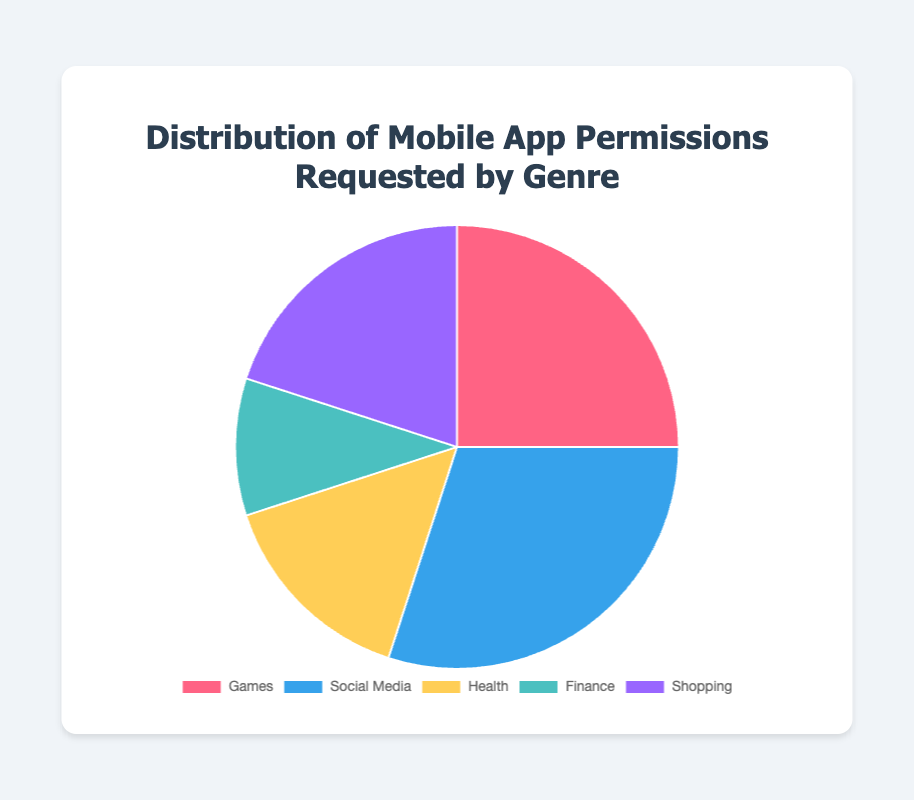What genre requests the highest percentage of permissions? The genre with the highest percentage of permissions is visible around the largest section of the pie chart. According to the data, Social Media requests the highest percentage of permissions at 30%.
Answer: Social Media Which genre requests the lowest percentage of permissions? The genre with the lowest percentage of permissions is visible around the smallest section of the pie chart. According to the data, Finance requests the lowest percentage at 10%.
Answer: Finance What is the total percentage of permissions requested by Games and Health combined? To find the total percentage of permissions requested by Games and Health, sum their individual percentages: 25 (Games) + 15 (Health) = 40.
Answer: 40 By how much does the percentage of permissions requested by Social Media exceed that requested by Shopping? To find how much more Social Media requests, subtract the percentage of Shopping from that of Social Media: 30 (Social Media) - 20 (Shopping) = 10.
Answer: 10 Which genre requests more permissions, Games or Shopping? By comparing the sizes of the sections in the pie chart, we see that Games (25%) requests more permissions than Shopping (20%).
Answer: Games How does the percentage of permissions for Shopping compare to that of Finance? The percentage requested by Shopping is larger as per the visual size of the sections. Shopping requests 20% while Finance requests 10%, so Shopping requests 10 percentage points more.
Answer: Shopping requests 10% more What is the average percentage of permissions requested across all genres? To find the average percentage, sum all genre percentages and divide by the number of genres: (25 + 30 + 15 + 10 + 20) / 5 = 20.
Answer: 20 By what fraction does the percentage of Health exceed that of Finance? To determine the fraction by which Health exceeds Finance, subtract Finance's percentage from Health's, then divide by Finance's percentage: (15 - 10) / 10 = 0.5 or 1/2.
Answer: 1/2 What color is used for the Shopping genre in the pie chart? The pie chart color segments are visually distinct, and Shopping is represented with a purple color.
Answer: purple What is the sum percentage of permissions requested by the Social Media and Finance genres? To find the total percentage of permissions requested by Social Media and Finance, sum their individual percentages: 30 (Social Media) + 10 (Finance) = 40.
Answer: 40 